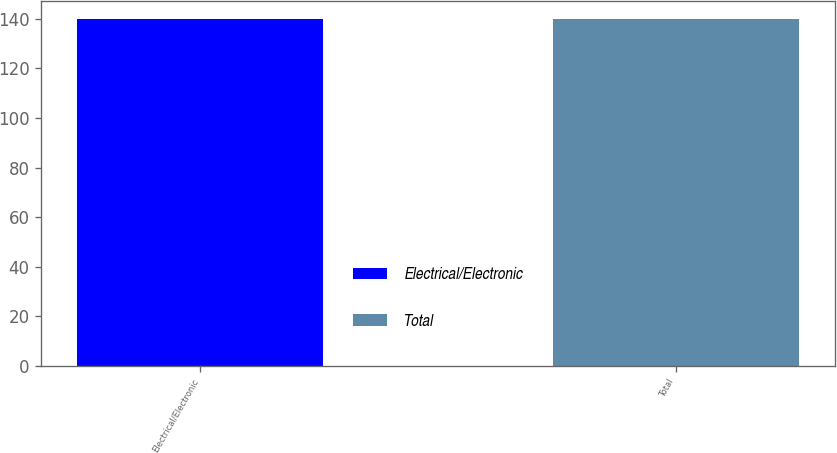Convert chart to OTSL. <chart><loc_0><loc_0><loc_500><loc_500><bar_chart><fcel>Electrical/Electronic<fcel>Total<nl><fcel>140<fcel>140.1<nl></chart> 